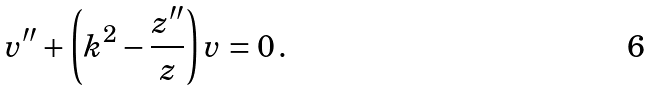<formula> <loc_0><loc_0><loc_500><loc_500>v ^ { \prime \prime } + \left ( k ^ { 2 } - \frac { z ^ { \prime \prime } } { z } \right ) v = 0 \, .</formula> 